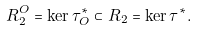Convert formula to latex. <formula><loc_0><loc_0><loc_500><loc_500>R ^ { O } _ { 2 } = \ker \tau ^ { * } _ { O } \subset R _ { 2 } = \ker \tau ^ { * } .</formula> 